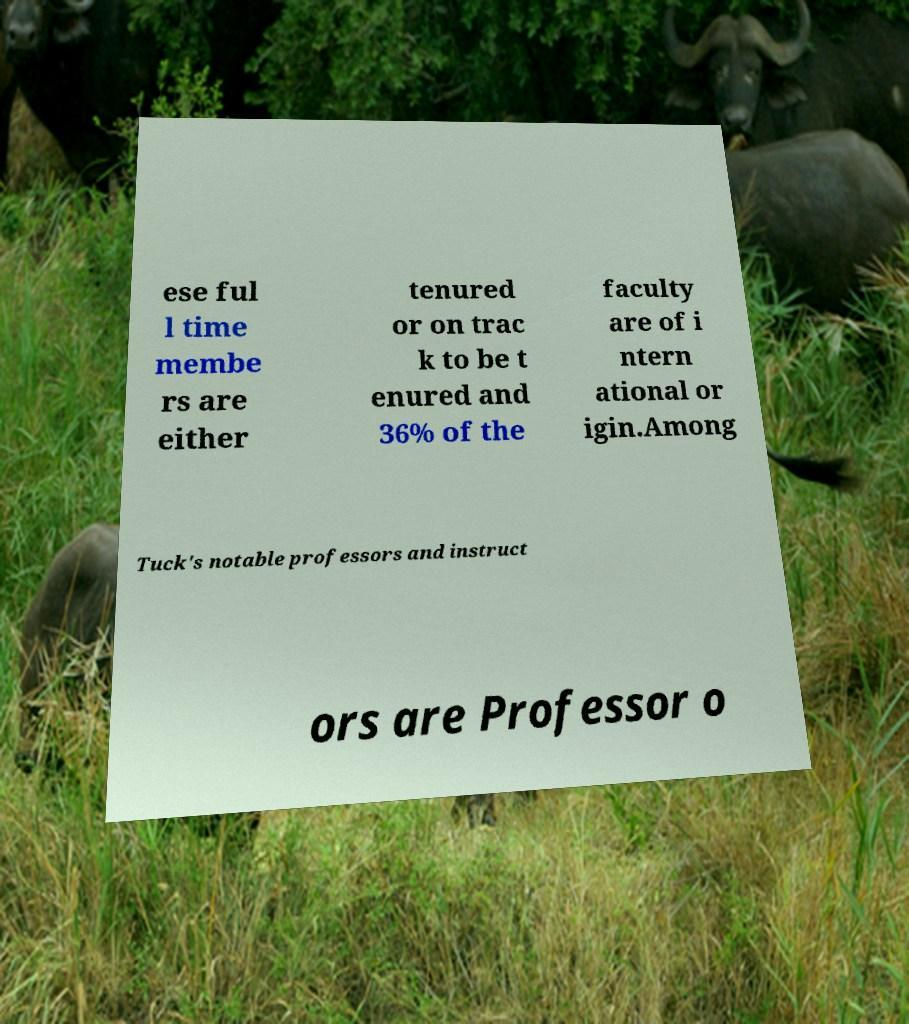Can you read and provide the text displayed in the image?This photo seems to have some interesting text. Can you extract and type it out for me? ese ful l time membe rs are either tenured or on trac k to be t enured and 36% of the faculty are of i ntern ational or igin.Among Tuck's notable professors and instruct ors are Professor o 